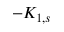<formula> <loc_0><loc_0><loc_500><loc_500>- K _ { 1 , s }</formula> 